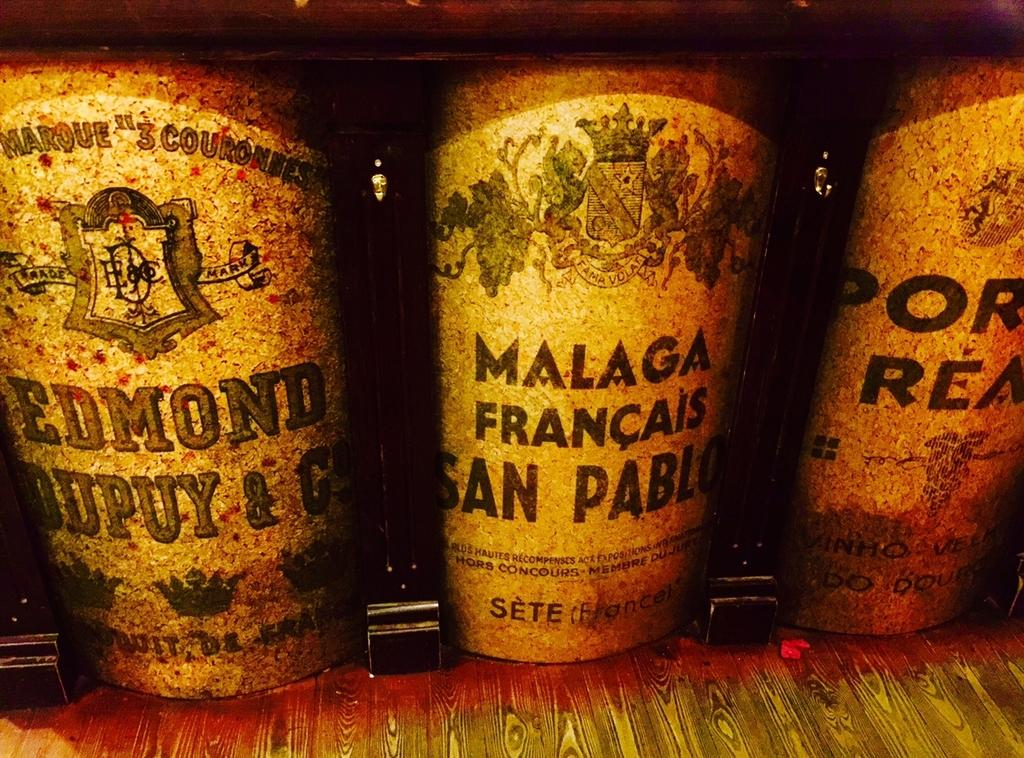<image>
Offer a succinct explanation of the picture presented. old bottles reading Malaga Francais and Edmond on a wood floor 